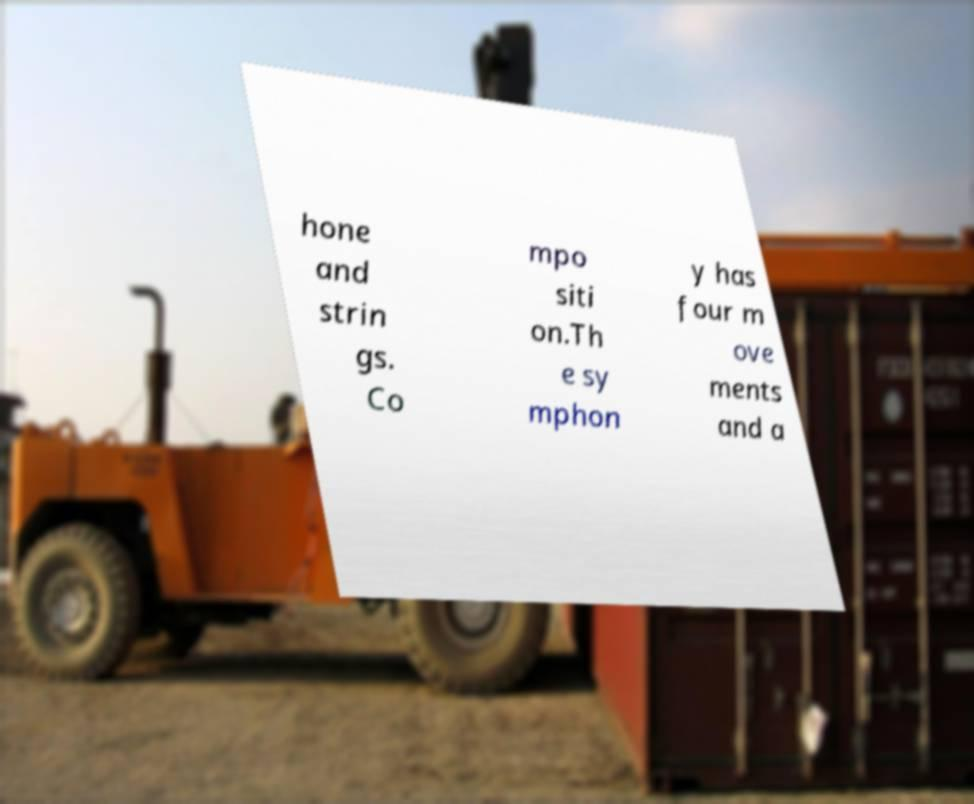Could you extract and type out the text from this image? hone and strin gs. Co mpo siti on.Th e sy mphon y has four m ove ments and a 